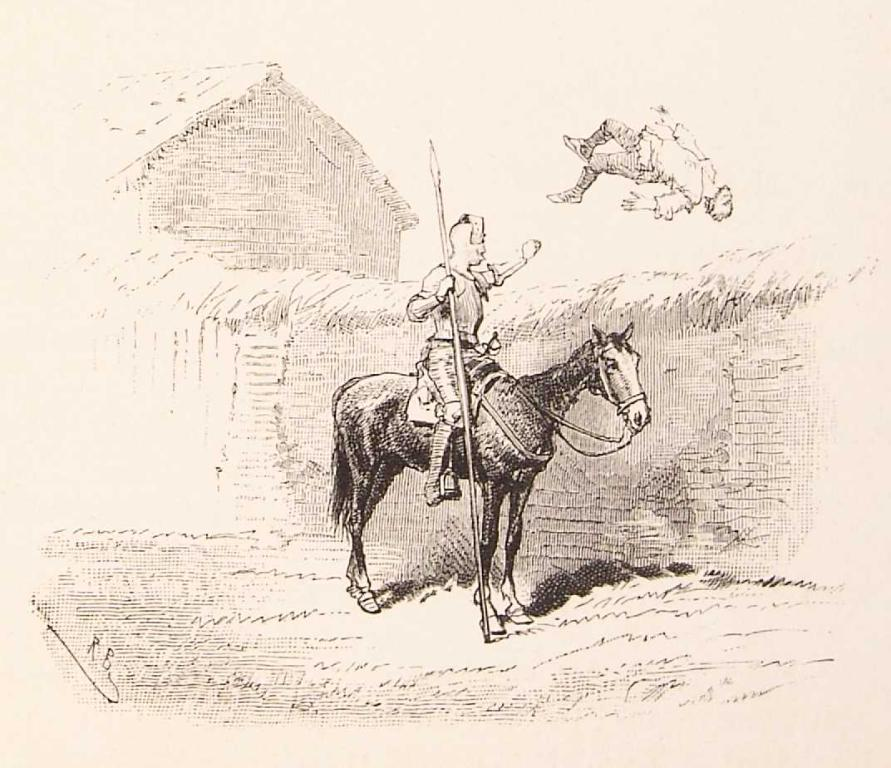What is depicted on the paper in the image? The paper contains an art of a person on a horse. Are there any other elements in the art besides the person on the horse? Yes, there is another person in the air in the art. What can be seen in the background of the image? There is a house visible in the background of the image. Can you tell me how many birds are flying around the house in the image? There are no birds visible in the image; it only features a house in the background. 